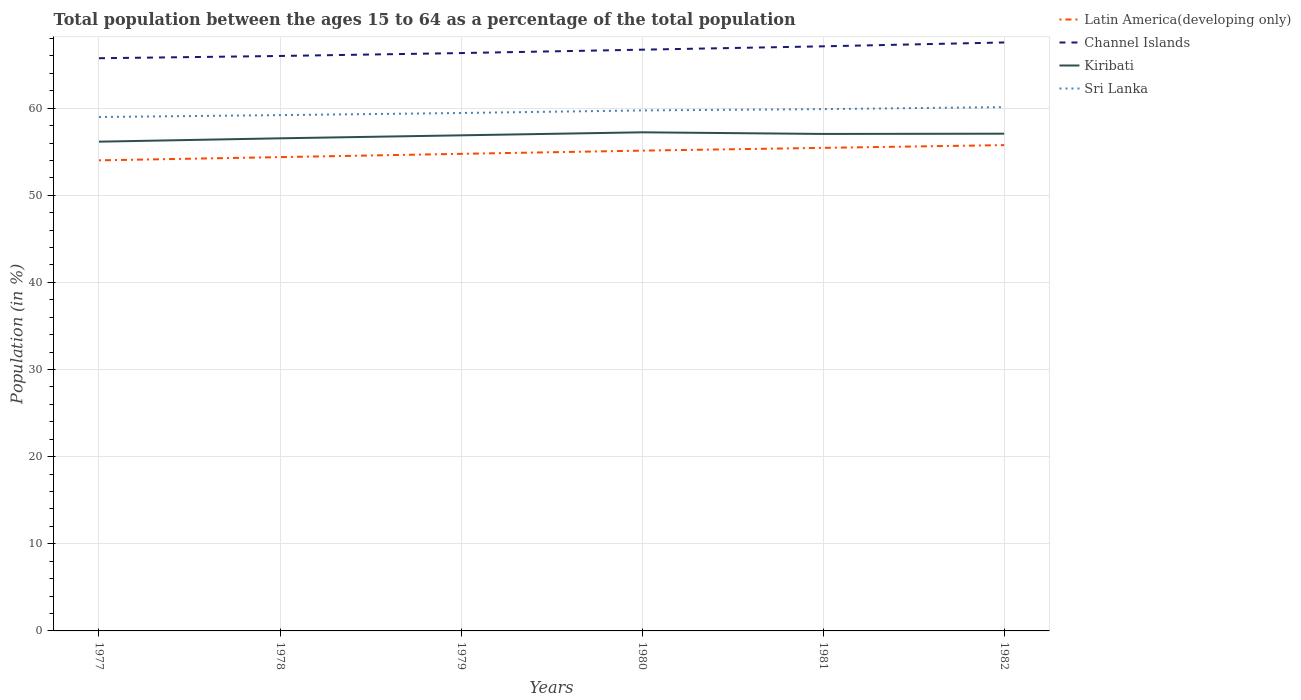Does the line corresponding to Channel Islands intersect with the line corresponding to Latin America(developing only)?
Give a very brief answer. No. Is the number of lines equal to the number of legend labels?
Provide a succinct answer. Yes. Across all years, what is the maximum percentage of the population ages 15 to 64 in Latin America(developing only)?
Offer a terse response. 54.01. In which year was the percentage of the population ages 15 to 64 in Channel Islands maximum?
Your answer should be compact. 1977. What is the total percentage of the population ages 15 to 64 in Kiribati in the graph?
Ensure brevity in your answer.  -0.39. What is the difference between the highest and the second highest percentage of the population ages 15 to 64 in Sri Lanka?
Keep it short and to the point. 1.14. What is the difference between the highest and the lowest percentage of the population ages 15 to 64 in Sri Lanka?
Offer a terse response. 3. Are the values on the major ticks of Y-axis written in scientific E-notation?
Offer a very short reply. No. Does the graph contain any zero values?
Provide a short and direct response. No. How are the legend labels stacked?
Offer a very short reply. Vertical. What is the title of the graph?
Offer a very short reply. Total population between the ages 15 to 64 as a percentage of the total population. What is the label or title of the X-axis?
Provide a short and direct response. Years. What is the Population (in %) in Latin America(developing only) in 1977?
Your answer should be compact. 54.01. What is the Population (in %) of Channel Islands in 1977?
Your answer should be very brief. 65.73. What is the Population (in %) of Kiribati in 1977?
Make the answer very short. 56.15. What is the Population (in %) of Sri Lanka in 1977?
Keep it short and to the point. 58.98. What is the Population (in %) of Latin America(developing only) in 1978?
Your answer should be compact. 54.38. What is the Population (in %) of Channel Islands in 1978?
Make the answer very short. 65.99. What is the Population (in %) of Kiribati in 1978?
Provide a short and direct response. 56.54. What is the Population (in %) in Sri Lanka in 1978?
Ensure brevity in your answer.  59.2. What is the Population (in %) in Latin America(developing only) in 1979?
Provide a short and direct response. 54.76. What is the Population (in %) of Channel Islands in 1979?
Your answer should be very brief. 66.32. What is the Population (in %) of Kiribati in 1979?
Your response must be concise. 56.88. What is the Population (in %) of Sri Lanka in 1979?
Make the answer very short. 59.44. What is the Population (in %) in Latin America(developing only) in 1980?
Offer a terse response. 55.12. What is the Population (in %) of Channel Islands in 1980?
Offer a very short reply. 66.71. What is the Population (in %) in Kiribati in 1980?
Provide a succinct answer. 57.23. What is the Population (in %) in Sri Lanka in 1980?
Your answer should be very brief. 59.74. What is the Population (in %) in Latin America(developing only) in 1981?
Ensure brevity in your answer.  55.44. What is the Population (in %) in Channel Islands in 1981?
Keep it short and to the point. 67.1. What is the Population (in %) of Kiribati in 1981?
Give a very brief answer. 57.04. What is the Population (in %) in Sri Lanka in 1981?
Provide a short and direct response. 59.89. What is the Population (in %) in Latin America(developing only) in 1982?
Make the answer very short. 55.76. What is the Population (in %) in Channel Islands in 1982?
Your answer should be compact. 67.54. What is the Population (in %) in Kiribati in 1982?
Provide a short and direct response. 57.07. What is the Population (in %) of Sri Lanka in 1982?
Provide a short and direct response. 60.12. Across all years, what is the maximum Population (in %) of Latin America(developing only)?
Give a very brief answer. 55.76. Across all years, what is the maximum Population (in %) in Channel Islands?
Your answer should be very brief. 67.54. Across all years, what is the maximum Population (in %) in Kiribati?
Offer a terse response. 57.23. Across all years, what is the maximum Population (in %) of Sri Lanka?
Keep it short and to the point. 60.12. Across all years, what is the minimum Population (in %) in Latin America(developing only)?
Make the answer very short. 54.01. Across all years, what is the minimum Population (in %) of Channel Islands?
Offer a terse response. 65.73. Across all years, what is the minimum Population (in %) in Kiribati?
Give a very brief answer. 56.15. Across all years, what is the minimum Population (in %) of Sri Lanka?
Your answer should be compact. 58.98. What is the total Population (in %) in Latin America(developing only) in the graph?
Your response must be concise. 329.47. What is the total Population (in %) in Channel Islands in the graph?
Offer a terse response. 399.39. What is the total Population (in %) in Kiribati in the graph?
Your response must be concise. 340.91. What is the total Population (in %) in Sri Lanka in the graph?
Your response must be concise. 357.38. What is the difference between the Population (in %) in Latin America(developing only) in 1977 and that in 1978?
Your answer should be very brief. -0.37. What is the difference between the Population (in %) of Channel Islands in 1977 and that in 1978?
Your answer should be compact. -0.26. What is the difference between the Population (in %) in Kiribati in 1977 and that in 1978?
Make the answer very short. -0.39. What is the difference between the Population (in %) in Sri Lanka in 1977 and that in 1978?
Offer a terse response. -0.22. What is the difference between the Population (in %) in Latin America(developing only) in 1977 and that in 1979?
Provide a succinct answer. -0.75. What is the difference between the Population (in %) of Channel Islands in 1977 and that in 1979?
Keep it short and to the point. -0.59. What is the difference between the Population (in %) in Kiribati in 1977 and that in 1979?
Offer a terse response. -0.73. What is the difference between the Population (in %) in Sri Lanka in 1977 and that in 1979?
Keep it short and to the point. -0.46. What is the difference between the Population (in %) in Latin America(developing only) in 1977 and that in 1980?
Make the answer very short. -1.11. What is the difference between the Population (in %) of Channel Islands in 1977 and that in 1980?
Give a very brief answer. -0.98. What is the difference between the Population (in %) of Kiribati in 1977 and that in 1980?
Give a very brief answer. -1.08. What is the difference between the Population (in %) in Sri Lanka in 1977 and that in 1980?
Your answer should be compact. -0.76. What is the difference between the Population (in %) in Latin America(developing only) in 1977 and that in 1981?
Make the answer very short. -1.43. What is the difference between the Population (in %) in Channel Islands in 1977 and that in 1981?
Offer a terse response. -1.37. What is the difference between the Population (in %) in Kiribati in 1977 and that in 1981?
Ensure brevity in your answer.  -0.89. What is the difference between the Population (in %) of Sri Lanka in 1977 and that in 1981?
Keep it short and to the point. -0.91. What is the difference between the Population (in %) in Latin America(developing only) in 1977 and that in 1982?
Give a very brief answer. -1.75. What is the difference between the Population (in %) of Channel Islands in 1977 and that in 1982?
Your answer should be compact. -1.81. What is the difference between the Population (in %) in Kiribati in 1977 and that in 1982?
Ensure brevity in your answer.  -0.92. What is the difference between the Population (in %) in Sri Lanka in 1977 and that in 1982?
Keep it short and to the point. -1.14. What is the difference between the Population (in %) in Latin America(developing only) in 1978 and that in 1979?
Offer a terse response. -0.38. What is the difference between the Population (in %) in Channel Islands in 1978 and that in 1979?
Give a very brief answer. -0.33. What is the difference between the Population (in %) of Kiribati in 1978 and that in 1979?
Your response must be concise. -0.34. What is the difference between the Population (in %) of Sri Lanka in 1978 and that in 1979?
Your response must be concise. -0.24. What is the difference between the Population (in %) of Latin America(developing only) in 1978 and that in 1980?
Your response must be concise. -0.74. What is the difference between the Population (in %) of Channel Islands in 1978 and that in 1980?
Provide a short and direct response. -0.72. What is the difference between the Population (in %) in Kiribati in 1978 and that in 1980?
Offer a very short reply. -0.69. What is the difference between the Population (in %) in Sri Lanka in 1978 and that in 1980?
Provide a short and direct response. -0.54. What is the difference between the Population (in %) of Latin America(developing only) in 1978 and that in 1981?
Your answer should be very brief. -1.06. What is the difference between the Population (in %) of Channel Islands in 1978 and that in 1981?
Offer a very short reply. -1.11. What is the difference between the Population (in %) of Kiribati in 1978 and that in 1981?
Your answer should be compact. -0.5. What is the difference between the Population (in %) in Sri Lanka in 1978 and that in 1981?
Offer a very short reply. -0.69. What is the difference between the Population (in %) of Latin America(developing only) in 1978 and that in 1982?
Your answer should be compact. -1.38. What is the difference between the Population (in %) in Channel Islands in 1978 and that in 1982?
Your answer should be compact. -1.55. What is the difference between the Population (in %) of Kiribati in 1978 and that in 1982?
Give a very brief answer. -0.53. What is the difference between the Population (in %) of Sri Lanka in 1978 and that in 1982?
Your response must be concise. -0.92. What is the difference between the Population (in %) of Latin America(developing only) in 1979 and that in 1980?
Ensure brevity in your answer.  -0.37. What is the difference between the Population (in %) of Channel Islands in 1979 and that in 1980?
Offer a terse response. -0.39. What is the difference between the Population (in %) in Kiribati in 1979 and that in 1980?
Your answer should be compact. -0.35. What is the difference between the Population (in %) of Sri Lanka in 1979 and that in 1980?
Give a very brief answer. -0.3. What is the difference between the Population (in %) in Latin America(developing only) in 1979 and that in 1981?
Make the answer very short. -0.69. What is the difference between the Population (in %) of Channel Islands in 1979 and that in 1981?
Provide a succinct answer. -0.77. What is the difference between the Population (in %) of Kiribati in 1979 and that in 1981?
Make the answer very short. -0.16. What is the difference between the Population (in %) in Sri Lanka in 1979 and that in 1981?
Your answer should be very brief. -0.45. What is the difference between the Population (in %) in Latin America(developing only) in 1979 and that in 1982?
Provide a short and direct response. -1. What is the difference between the Population (in %) in Channel Islands in 1979 and that in 1982?
Offer a very short reply. -1.22. What is the difference between the Population (in %) of Kiribati in 1979 and that in 1982?
Offer a terse response. -0.19. What is the difference between the Population (in %) in Sri Lanka in 1979 and that in 1982?
Your response must be concise. -0.68. What is the difference between the Population (in %) of Latin America(developing only) in 1980 and that in 1981?
Provide a succinct answer. -0.32. What is the difference between the Population (in %) in Channel Islands in 1980 and that in 1981?
Your answer should be very brief. -0.38. What is the difference between the Population (in %) in Kiribati in 1980 and that in 1981?
Your response must be concise. 0.19. What is the difference between the Population (in %) in Sri Lanka in 1980 and that in 1981?
Keep it short and to the point. -0.15. What is the difference between the Population (in %) of Latin America(developing only) in 1980 and that in 1982?
Make the answer very short. -0.63. What is the difference between the Population (in %) of Channel Islands in 1980 and that in 1982?
Provide a succinct answer. -0.83. What is the difference between the Population (in %) in Kiribati in 1980 and that in 1982?
Provide a succinct answer. 0.16. What is the difference between the Population (in %) of Sri Lanka in 1980 and that in 1982?
Provide a succinct answer. -0.38. What is the difference between the Population (in %) of Latin America(developing only) in 1981 and that in 1982?
Provide a succinct answer. -0.32. What is the difference between the Population (in %) in Channel Islands in 1981 and that in 1982?
Provide a succinct answer. -0.44. What is the difference between the Population (in %) in Kiribati in 1981 and that in 1982?
Provide a short and direct response. -0.03. What is the difference between the Population (in %) of Sri Lanka in 1981 and that in 1982?
Your answer should be compact. -0.23. What is the difference between the Population (in %) in Latin America(developing only) in 1977 and the Population (in %) in Channel Islands in 1978?
Provide a short and direct response. -11.98. What is the difference between the Population (in %) of Latin America(developing only) in 1977 and the Population (in %) of Kiribati in 1978?
Offer a terse response. -2.53. What is the difference between the Population (in %) of Latin America(developing only) in 1977 and the Population (in %) of Sri Lanka in 1978?
Your answer should be very brief. -5.19. What is the difference between the Population (in %) in Channel Islands in 1977 and the Population (in %) in Kiribati in 1978?
Provide a short and direct response. 9.19. What is the difference between the Population (in %) in Channel Islands in 1977 and the Population (in %) in Sri Lanka in 1978?
Give a very brief answer. 6.53. What is the difference between the Population (in %) of Kiribati in 1977 and the Population (in %) of Sri Lanka in 1978?
Your answer should be compact. -3.05. What is the difference between the Population (in %) in Latin America(developing only) in 1977 and the Population (in %) in Channel Islands in 1979?
Ensure brevity in your answer.  -12.31. What is the difference between the Population (in %) in Latin America(developing only) in 1977 and the Population (in %) in Kiribati in 1979?
Ensure brevity in your answer.  -2.87. What is the difference between the Population (in %) of Latin America(developing only) in 1977 and the Population (in %) of Sri Lanka in 1979?
Give a very brief answer. -5.43. What is the difference between the Population (in %) of Channel Islands in 1977 and the Population (in %) of Kiribati in 1979?
Offer a terse response. 8.85. What is the difference between the Population (in %) of Channel Islands in 1977 and the Population (in %) of Sri Lanka in 1979?
Offer a terse response. 6.29. What is the difference between the Population (in %) of Kiribati in 1977 and the Population (in %) of Sri Lanka in 1979?
Your answer should be compact. -3.29. What is the difference between the Population (in %) of Latin America(developing only) in 1977 and the Population (in %) of Channel Islands in 1980?
Offer a terse response. -12.7. What is the difference between the Population (in %) of Latin America(developing only) in 1977 and the Population (in %) of Kiribati in 1980?
Offer a very short reply. -3.22. What is the difference between the Population (in %) of Latin America(developing only) in 1977 and the Population (in %) of Sri Lanka in 1980?
Keep it short and to the point. -5.73. What is the difference between the Population (in %) of Channel Islands in 1977 and the Population (in %) of Kiribati in 1980?
Your answer should be compact. 8.5. What is the difference between the Population (in %) of Channel Islands in 1977 and the Population (in %) of Sri Lanka in 1980?
Provide a succinct answer. 5.99. What is the difference between the Population (in %) in Kiribati in 1977 and the Population (in %) in Sri Lanka in 1980?
Offer a very short reply. -3.59. What is the difference between the Population (in %) of Latin America(developing only) in 1977 and the Population (in %) of Channel Islands in 1981?
Your answer should be very brief. -13.09. What is the difference between the Population (in %) in Latin America(developing only) in 1977 and the Population (in %) in Kiribati in 1981?
Your answer should be very brief. -3.03. What is the difference between the Population (in %) of Latin America(developing only) in 1977 and the Population (in %) of Sri Lanka in 1981?
Provide a short and direct response. -5.88. What is the difference between the Population (in %) in Channel Islands in 1977 and the Population (in %) in Kiribati in 1981?
Provide a short and direct response. 8.69. What is the difference between the Population (in %) of Channel Islands in 1977 and the Population (in %) of Sri Lanka in 1981?
Give a very brief answer. 5.84. What is the difference between the Population (in %) in Kiribati in 1977 and the Population (in %) in Sri Lanka in 1981?
Offer a terse response. -3.74. What is the difference between the Population (in %) in Latin America(developing only) in 1977 and the Population (in %) in Channel Islands in 1982?
Offer a very short reply. -13.53. What is the difference between the Population (in %) in Latin America(developing only) in 1977 and the Population (in %) in Kiribati in 1982?
Your response must be concise. -3.06. What is the difference between the Population (in %) in Latin America(developing only) in 1977 and the Population (in %) in Sri Lanka in 1982?
Ensure brevity in your answer.  -6.11. What is the difference between the Population (in %) in Channel Islands in 1977 and the Population (in %) in Kiribati in 1982?
Give a very brief answer. 8.66. What is the difference between the Population (in %) in Channel Islands in 1977 and the Population (in %) in Sri Lanka in 1982?
Your response must be concise. 5.61. What is the difference between the Population (in %) in Kiribati in 1977 and the Population (in %) in Sri Lanka in 1982?
Provide a succinct answer. -3.97. What is the difference between the Population (in %) in Latin America(developing only) in 1978 and the Population (in %) in Channel Islands in 1979?
Give a very brief answer. -11.94. What is the difference between the Population (in %) in Latin America(developing only) in 1978 and the Population (in %) in Kiribati in 1979?
Keep it short and to the point. -2.5. What is the difference between the Population (in %) of Latin America(developing only) in 1978 and the Population (in %) of Sri Lanka in 1979?
Offer a very short reply. -5.06. What is the difference between the Population (in %) in Channel Islands in 1978 and the Population (in %) in Kiribati in 1979?
Your answer should be compact. 9.11. What is the difference between the Population (in %) in Channel Islands in 1978 and the Population (in %) in Sri Lanka in 1979?
Offer a very short reply. 6.55. What is the difference between the Population (in %) of Kiribati in 1978 and the Population (in %) of Sri Lanka in 1979?
Your answer should be compact. -2.9. What is the difference between the Population (in %) of Latin America(developing only) in 1978 and the Population (in %) of Channel Islands in 1980?
Keep it short and to the point. -12.33. What is the difference between the Population (in %) of Latin America(developing only) in 1978 and the Population (in %) of Kiribati in 1980?
Your answer should be compact. -2.85. What is the difference between the Population (in %) of Latin America(developing only) in 1978 and the Population (in %) of Sri Lanka in 1980?
Provide a succinct answer. -5.36. What is the difference between the Population (in %) in Channel Islands in 1978 and the Population (in %) in Kiribati in 1980?
Your answer should be very brief. 8.76. What is the difference between the Population (in %) in Channel Islands in 1978 and the Population (in %) in Sri Lanka in 1980?
Provide a short and direct response. 6.25. What is the difference between the Population (in %) in Kiribati in 1978 and the Population (in %) in Sri Lanka in 1980?
Your response must be concise. -3.2. What is the difference between the Population (in %) of Latin America(developing only) in 1978 and the Population (in %) of Channel Islands in 1981?
Ensure brevity in your answer.  -12.72. What is the difference between the Population (in %) in Latin America(developing only) in 1978 and the Population (in %) in Kiribati in 1981?
Ensure brevity in your answer.  -2.66. What is the difference between the Population (in %) of Latin America(developing only) in 1978 and the Population (in %) of Sri Lanka in 1981?
Your answer should be very brief. -5.51. What is the difference between the Population (in %) in Channel Islands in 1978 and the Population (in %) in Kiribati in 1981?
Make the answer very short. 8.95. What is the difference between the Population (in %) of Channel Islands in 1978 and the Population (in %) of Sri Lanka in 1981?
Your answer should be very brief. 6.1. What is the difference between the Population (in %) of Kiribati in 1978 and the Population (in %) of Sri Lanka in 1981?
Keep it short and to the point. -3.35. What is the difference between the Population (in %) in Latin America(developing only) in 1978 and the Population (in %) in Channel Islands in 1982?
Provide a succinct answer. -13.16. What is the difference between the Population (in %) in Latin America(developing only) in 1978 and the Population (in %) in Kiribati in 1982?
Keep it short and to the point. -2.69. What is the difference between the Population (in %) in Latin America(developing only) in 1978 and the Population (in %) in Sri Lanka in 1982?
Offer a terse response. -5.74. What is the difference between the Population (in %) in Channel Islands in 1978 and the Population (in %) in Kiribati in 1982?
Make the answer very short. 8.92. What is the difference between the Population (in %) in Channel Islands in 1978 and the Population (in %) in Sri Lanka in 1982?
Offer a terse response. 5.87. What is the difference between the Population (in %) of Kiribati in 1978 and the Population (in %) of Sri Lanka in 1982?
Keep it short and to the point. -3.58. What is the difference between the Population (in %) in Latin America(developing only) in 1979 and the Population (in %) in Channel Islands in 1980?
Your answer should be very brief. -11.96. What is the difference between the Population (in %) of Latin America(developing only) in 1979 and the Population (in %) of Kiribati in 1980?
Offer a very short reply. -2.47. What is the difference between the Population (in %) of Latin America(developing only) in 1979 and the Population (in %) of Sri Lanka in 1980?
Provide a succinct answer. -4.99. What is the difference between the Population (in %) in Channel Islands in 1979 and the Population (in %) in Kiribati in 1980?
Offer a very short reply. 9.09. What is the difference between the Population (in %) in Channel Islands in 1979 and the Population (in %) in Sri Lanka in 1980?
Your answer should be compact. 6.58. What is the difference between the Population (in %) of Kiribati in 1979 and the Population (in %) of Sri Lanka in 1980?
Provide a succinct answer. -2.86. What is the difference between the Population (in %) of Latin America(developing only) in 1979 and the Population (in %) of Channel Islands in 1981?
Provide a succinct answer. -12.34. What is the difference between the Population (in %) in Latin America(developing only) in 1979 and the Population (in %) in Kiribati in 1981?
Ensure brevity in your answer.  -2.29. What is the difference between the Population (in %) in Latin America(developing only) in 1979 and the Population (in %) in Sri Lanka in 1981?
Make the answer very short. -5.13. What is the difference between the Population (in %) in Channel Islands in 1979 and the Population (in %) in Kiribati in 1981?
Your answer should be compact. 9.28. What is the difference between the Population (in %) in Channel Islands in 1979 and the Population (in %) in Sri Lanka in 1981?
Keep it short and to the point. 6.43. What is the difference between the Population (in %) of Kiribati in 1979 and the Population (in %) of Sri Lanka in 1981?
Your answer should be compact. -3.01. What is the difference between the Population (in %) of Latin America(developing only) in 1979 and the Population (in %) of Channel Islands in 1982?
Ensure brevity in your answer.  -12.78. What is the difference between the Population (in %) of Latin America(developing only) in 1979 and the Population (in %) of Kiribati in 1982?
Offer a terse response. -2.31. What is the difference between the Population (in %) of Latin America(developing only) in 1979 and the Population (in %) of Sri Lanka in 1982?
Provide a short and direct response. -5.36. What is the difference between the Population (in %) of Channel Islands in 1979 and the Population (in %) of Kiribati in 1982?
Provide a succinct answer. 9.25. What is the difference between the Population (in %) of Channel Islands in 1979 and the Population (in %) of Sri Lanka in 1982?
Your answer should be very brief. 6.2. What is the difference between the Population (in %) of Kiribati in 1979 and the Population (in %) of Sri Lanka in 1982?
Make the answer very short. -3.24. What is the difference between the Population (in %) of Latin America(developing only) in 1980 and the Population (in %) of Channel Islands in 1981?
Offer a terse response. -11.97. What is the difference between the Population (in %) in Latin America(developing only) in 1980 and the Population (in %) in Kiribati in 1981?
Give a very brief answer. -1.92. What is the difference between the Population (in %) in Latin America(developing only) in 1980 and the Population (in %) in Sri Lanka in 1981?
Ensure brevity in your answer.  -4.77. What is the difference between the Population (in %) in Channel Islands in 1980 and the Population (in %) in Kiribati in 1981?
Offer a very short reply. 9.67. What is the difference between the Population (in %) of Channel Islands in 1980 and the Population (in %) of Sri Lanka in 1981?
Provide a short and direct response. 6.82. What is the difference between the Population (in %) in Kiribati in 1980 and the Population (in %) in Sri Lanka in 1981?
Your response must be concise. -2.66. What is the difference between the Population (in %) in Latin America(developing only) in 1980 and the Population (in %) in Channel Islands in 1982?
Your answer should be compact. -12.41. What is the difference between the Population (in %) of Latin America(developing only) in 1980 and the Population (in %) of Kiribati in 1982?
Ensure brevity in your answer.  -1.94. What is the difference between the Population (in %) in Latin America(developing only) in 1980 and the Population (in %) in Sri Lanka in 1982?
Offer a very short reply. -5. What is the difference between the Population (in %) of Channel Islands in 1980 and the Population (in %) of Kiribati in 1982?
Keep it short and to the point. 9.64. What is the difference between the Population (in %) of Channel Islands in 1980 and the Population (in %) of Sri Lanka in 1982?
Provide a short and direct response. 6.59. What is the difference between the Population (in %) in Kiribati in 1980 and the Population (in %) in Sri Lanka in 1982?
Make the answer very short. -2.89. What is the difference between the Population (in %) of Latin America(developing only) in 1981 and the Population (in %) of Channel Islands in 1982?
Make the answer very short. -12.1. What is the difference between the Population (in %) in Latin America(developing only) in 1981 and the Population (in %) in Kiribati in 1982?
Ensure brevity in your answer.  -1.63. What is the difference between the Population (in %) of Latin America(developing only) in 1981 and the Population (in %) of Sri Lanka in 1982?
Your answer should be compact. -4.68. What is the difference between the Population (in %) in Channel Islands in 1981 and the Population (in %) in Kiribati in 1982?
Offer a very short reply. 10.03. What is the difference between the Population (in %) in Channel Islands in 1981 and the Population (in %) in Sri Lanka in 1982?
Provide a succinct answer. 6.98. What is the difference between the Population (in %) in Kiribati in 1981 and the Population (in %) in Sri Lanka in 1982?
Provide a succinct answer. -3.08. What is the average Population (in %) of Latin America(developing only) per year?
Provide a succinct answer. 54.91. What is the average Population (in %) of Channel Islands per year?
Make the answer very short. 66.56. What is the average Population (in %) in Kiribati per year?
Ensure brevity in your answer.  56.82. What is the average Population (in %) in Sri Lanka per year?
Give a very brief answer. 59.56. In the year 1977, what is the difference between the Population (in %) in Latin America(developing only) and Population (in %) in Channel Islands?
Provide a succinct answer. -11.72. In the year 1977, what is the difference between the Population (in %) of Latin America(developing only) and Population (in %) of Kiribati?
Offer a very short reply. -2.14. In the year 1977, what is the difference between the Population (in %) in Latin America(developing only) and Population (in %) in Sri Lanka?
Your response must be concise. -4.97. In the year 1977, what is the difference between the Population (in %) of Channel Islands and Population (in %) of Kiribati?
Provide a short and direct response. 9.58. In the year 1977, what is the difference between the Population (in %) of Channel Islands and Population (in %) of Sri Lanka?
Offer a terse response. 6.75. In the year 1977, what is the difference between the Population (in %) in Kiribati and Population (in %) in Sri Lanka?
Offer a very short reply. -2.83. In the year 1978, what is the difference between the Population (in %) of Latin America(developing only) and Population (in %) of Channel Islands?
Give a very brief answer. -11.61. In the year 1978, what is the difference between the Population (in %) in Latin America(developing only) and Population (in %) in Kiribati?
Offer a terse response. -2.16. In the year 1978, what is the difference between the Population (in %) of Latin America(developing only) and Population (in %) of Sri Lanka?
Offer a terse response. -4.82. In the year 1978, what is the difference between the Population (in %) in Channel Islands and Population (in %) in Kiribati?
Your answer should be very brief. 9.45. In the year 1978, what is the difference between the Population (in %) of Channel Islands and Population (in %) of Sri Lanka?
Provide a succinct answer. 6.79. In the year 1978, what is the difference between the Population (in %) of Kiribati and Population (in %) of Sri Lanka?
Make the answer very short. -2.66. In the year 1979, what is the difference between the Population (in %) in Latin America(developing only) and Population (in %) in Channel Islands?
Your response must be concise. -11.57. In the year 1979, what is the difference between the Population (in %) of Latin America(developing only) and Population (in %) of Kiribati?
Your answer should be compact. -2.13. In the year 1979, what is the difference between the Population (in %) in Latin America(developing only) and Population (in %) in Sri Lanka?
Give a very brief answer. -4.69. In the year 1979, what is the difference between the Population (in %) in Channel Islands and Population (in %) in Kiribati?
Ensure brevity in your answer.  9.44. In the year 1979, what is the difference between the Population (in %) in Channel Islands and Population (in %) in Sri Lanka?
Your answer should be compact. 6.88. In the year 1979, what is the difference between the Population (in %) of Kiribati and Population (in %) of Sri Lanka?
Ensure brevity in your answer.  -2.56. In the year 1980, what is the difference between the Population (in %) in Latin America(developing only) and Population (in %) in Channel Islands?
Your response must be concise. -11.59. In the year 1980, what is the difference between the Population (in %) of Latin America(developing only) and Population (in %) of Kiribati?
Make the answer very short. -2.1. In the year 1980, what is the difference between the Population (in %) in Latin America(developing only) and Population (in %) in Sri Lanka?
Provide a succinct answer. -4.62. In the year 1980, what is the difference between the Population (in %) of Channel Islands and Population (in %) of Kiribati?
Ensure brevity in your answer.  9.48. In the year 1980, what is the difference between the Population (in %) of Channel Islands and Population (in %) of Sri Lanka?
Offer a very short reply. 6.97. In the year 1980, what is the difference between the Population (in %) of Kiribati and Population (in %) of Sri Lanka?
Offer a very short reply. -2.51. In the year 1981, what is the difference between the Population (in %) of Latin America(developing only) and Population (in %) of Channel Islands?
Provide a short and direct response. -11.65. In the year 1981, what is the difference between the Population (in %) in Latin America(developing only) and Population (in %) in Kiribati?
Give a very brief answer. -1.6. In the year 1981, what is the difference between the Population (in %) in Latin America(developing only) and Population (in %) in Sri Lanka?
Provide a short and direct response. -4.45. In the year 1981, what is the difference between the Population (in %) in Channel Islands and Population (in %) in Kiribati?
Provide a succinct answer. 10.05. In the year 1981, what is the difference between the Population (in %) of Channel Islands and Population (in %) of Sri Lanka?
Provide a succinct answer. 7.21. In the year 1981, what is the difference between the Population (in %) in Kiribati and Population (in %) in Sri Lanka?
Provide a short and direct response. -2.85. In the year 1982, what is the difference between the Population (in %) in Latin America(developing only) and Population (in %) in Channel Islands?
Your response must be concise. -11.78. In the year 1982, what is the difference between the Population (in %) in Latin America(developing only) and Population (in %) in Kiribati?
Give a very brief answer. -1.31. In the year 1982, what is the difference between the Population (in %) of Latin America(developing only) and Population (in %) of Sri Lanka?
Keep it short and to the point. -4.36. In the year 1982, what is the difference between the Population (in %) of Channel Islands and Population (in %) of Kiribati?
Provide a succinct answer. 10.47. In the year 1982, what is the difference between the Population (in %) in Channel Islands and Population (in %) in Sri Lanka?
Ensure brevity in your answer.  7.42. In the year 1982, what is the difference between the Population (in %) in Kiribati and Population (in %) in Sri Lanka?
Offer a terse response. -3.05. What is the ratio of the Population (in %) of Latin America(developing only) in 1977 to that in 1978?
Your answer should be compact. 0.99. What is the ratio of the Population (in %) of Channel Islands in 1977 to that in 1978?
Make the answer very short. 1. What is the ratio of the Population (in %) of Kiribati in 1977 to that in 1978?
Give a very brief answer. 0.99. What is the ratio of the Population (in %) in Sri Lanka in 1977 to that in 1978?
Offer a very short reply. 1. What is the ratio of the Population (in %) in Latin America(developing only) in 1977 to that in 1979?
Make the answer very short. 0.99. What is the ratio of the Population (in %) of Kiribati in 1977 to that in 1979?
Make the answer very short. 0.99. What is the ratio of the Population (in %) in Latin America(developing only) in 1977 to that in 1980?
Provide a short and direct response. 0.98. What is the ratio of the Population (in %) in Channel Islands in 1977 to that in 1980?
Offer a very short reply. 0.99. What is the ratio of the Population (in %) of Kiribati in 1977 to that in 1980?
Provide a short and direct response. 0.98. What is the ratio of the Population (in %) of Sri Lanka in 1977 to that in 1980?
Keep it short and to the point. 0.99. What is the ratio of the Population (in %) of Latin America(developing only) in 1977 to that in 1981?
Your answer should be very brief. 0.97. What is the ratio of the Population (in %) of Channel Islands in 1977 to that in 1981?
Your response must be concise. 0.98. What is the ratio of the Population (in %) of Kiribati in 1977 to that in 1981?
Offer a terse response. 0.98. What is the ratio of the Population (in %) of Sri Lanka in 1977 to that in 1981?
Offer a terse response. 0.98. What is the ratio of the Population (in %) of Latin America(developing only) in 1977 to that in 1982?
Provide a succinct answer. 0.97. What is the ratio of the Population (in %) in Channel Islands in 1977 to that in 1982?
Offer a terse response. 0.97. What is the ratio of the Population (in %) in Kiribati in 1977 to that in 1982?
Keep it short and to the point. 0.98. What is the ratio of the Population (in %) in Sri Lanka in 1977 to that in 1982?
Ensure brevity in your answer.  0.98. What is the ratio of the Population (in %) in Channel Islands in 1978 to that in 1979?
Give a very brief answer. 0.99. What is the ratio of the Population (in %) of Sri Lanka in 1978 to that in 1979?
Your response must be concise. 1. What is the ratio of the Population (in %) in Latin America(developing only) in 1978 to that in 1980?
Your response must be concise. 0.99. What is the ratio of the Population (in %) of Channel Islands in 1978 to that in 1980?
Ensure brevity in your answer.  0.99. What is the ratio of the Population (in %) in Kiribati in 1978 to that in 1980?
Offer a very short reply. 0.99. What is the ratio of the Population (in %) in Sri Lanka in 1978 to that in 1980?
Your answer should be very brief. 0.99. What is the ratio of the Population (in %) of Latin America(developing only) in 1978 to that in 1981?
Provide a succinct answer. 0.98. What is the ratio of the Population (in %) in Channel Islands in 1978 to that in 1981?
Ensure brevity in your answer.  0.98. What is the ratio of the Population (in %) of Latin America(developing only) in 1978 to that in 1982?
Ensure brevity in your answer.  0.98. What is the ratio of the Population (in %) of Channel Islands in 1978 to that in 1982?
Make the answer very short. 0.98. What is the ratio of the Population (in %) in Sri Lanka in 1978 to that in 1982?
Provide a succinct answer. 0.98. What is the ratio of the Population (in %) in Latin America(developing only) in 1979 to that in 1980?
Make the answer very short. 0.99. What is the ratio of the Population (in %) of Channel Islands in 1979 to that in 1980?
Provide a succinct answer. 0.99. What is the ratio of the Population (in %) in Sri Lanka in 1979 to that in 1980?
Make the answer very short. 0.99. What is the ratio of the Population (in %) of Latin America(developing only) in 1979 to that in 1981?
Provide a succinct answer. 0.99. What is the ratio of the Population (in %) in Channel Islands in 1979 to that in 1982?
Offer a terse response. 0.98. What is the ratio of the Population (in %) of Kiribati in 1979 to that in 1982?
Offer a terse response. 1. What is the ratio of the Population (in %) of Sri Lanka in 1979 to that in 1982?
Your answer should be very brief. 0.99. What is the ratio of the Population (in %) of Kiribati in 1980 to that in 1982?
Provide a succinct answer. 1. What is the ratio of the Population (in %) of Sri Lanka in 1980 to that in 1982?
Your answer should be very brief. 0.99. What is the ratio of the Population (in %) of Kiribati in 1981 to that in 1982?
Give a very brief answer. 1. What is the ratio of the Population (in %) of Sri Lanka in 1981 to that in 1982?
Your answer should be very brief. 1. What is the difference between the highest and the second highest Population (in %) in Latin America(developing only)?
Ensure brevity in your answer.  0.32. What is the difference between the highest and the second highest Population (in %) in Channel Islands?
Give a very brief answer. 0.44. What is the difference between the highest and the second highest Population (in %) of Kiribati?
Ensure brevity in your answer.  0.16. What is the difference between the highest and the second highest Population (in %) of Sri Lanka?
Your answer should be compact. 0.23. What is the difference between the highest and the lowest Population (in %) of Latin America(developing only)?
Ensure brevity in your answer.  1.75. What is the difference between the highest and the lowest Population (in %) of Channel Islands?
Ensure brevity in your answer.  1.81. What is the difference between the highest and the lowest Population (in %) of Kiribati?
Make the answer very short. 1.08. What is the difference between the highest and the lowest Population (in %) of Sri Lanka?
Ensure brevity in your answer.  1.14. 